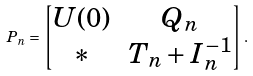<formula> <loc_0><loc_0><loc_500><loc_500>P _ { n } = \begin{bmatrix} U ( 0 ) & Q _ { n } \\ \ast & T _ { n } + I _ { n } ^ { - 1 } \end{bmatrix} .</formula> 